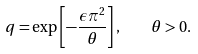Convert formula to latex. <formula><loc_0><loc_0><loc_500><loc_500>q = \exp \left [ - \frac { \epsilon \pi ^ { 2 } } { \theta } \right ] , \quad \theta > 0 .</formula> 